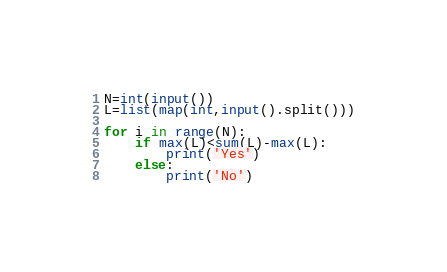<code> <loc_0><loc_0><loc_500><loc_500><_Python_>N=int(input())
L=list(map(int,input().split()))

for i in range(N):
    if max(L)<sum(L)-max(L):
        print('Yes')
    else:
        print('No')</code> 